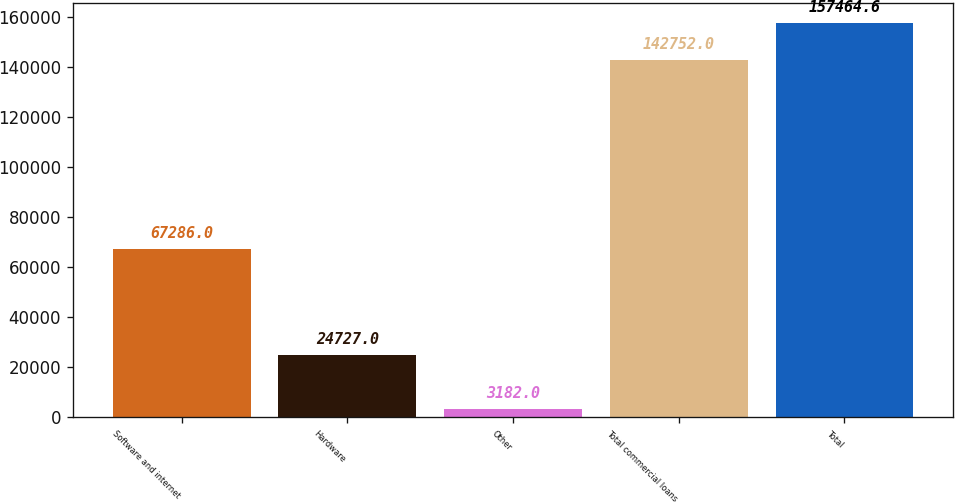Convert chart. <chart><loc_0><loc_0><loc_500><loc_500><bar_chart><fcel>Software and internet<fcel>Hardware<fcel>Other<fcel>Total commercial loans<fcel>Total<nl><fcel>67286<fcel>24727<fcel>3182<fcel>142752<fcel>157465<nl></chart> 